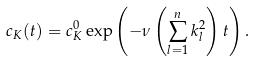Convert formula to latex. <formula><loc_0><loc_0><loc_500><loc_500>c _ { K } ( t ) = c _ { K } ^ { 0 } \exp \left ( - \nu \left ( \sum _ { l = 1 } ^ { n } k _ { l } ^ { 2 } \right ) t \right ) .</formula> 